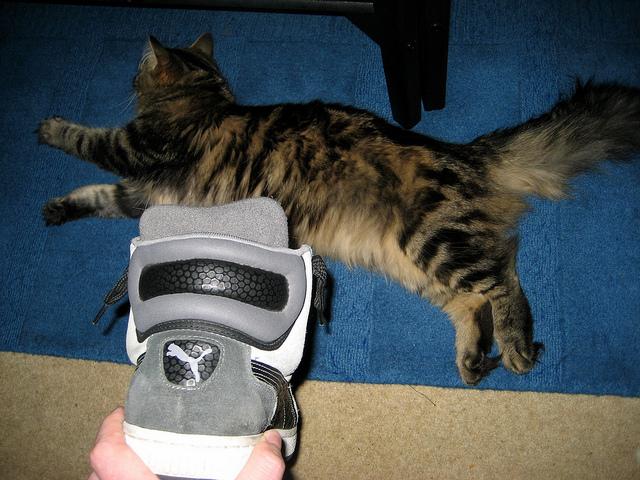What brand of shoe is the person holding?
Quick response, please. Puma. How long is the fur of the cat?
Give a very brief answer. Medium. What is the person holding?
Concise answer only. Shoe. 